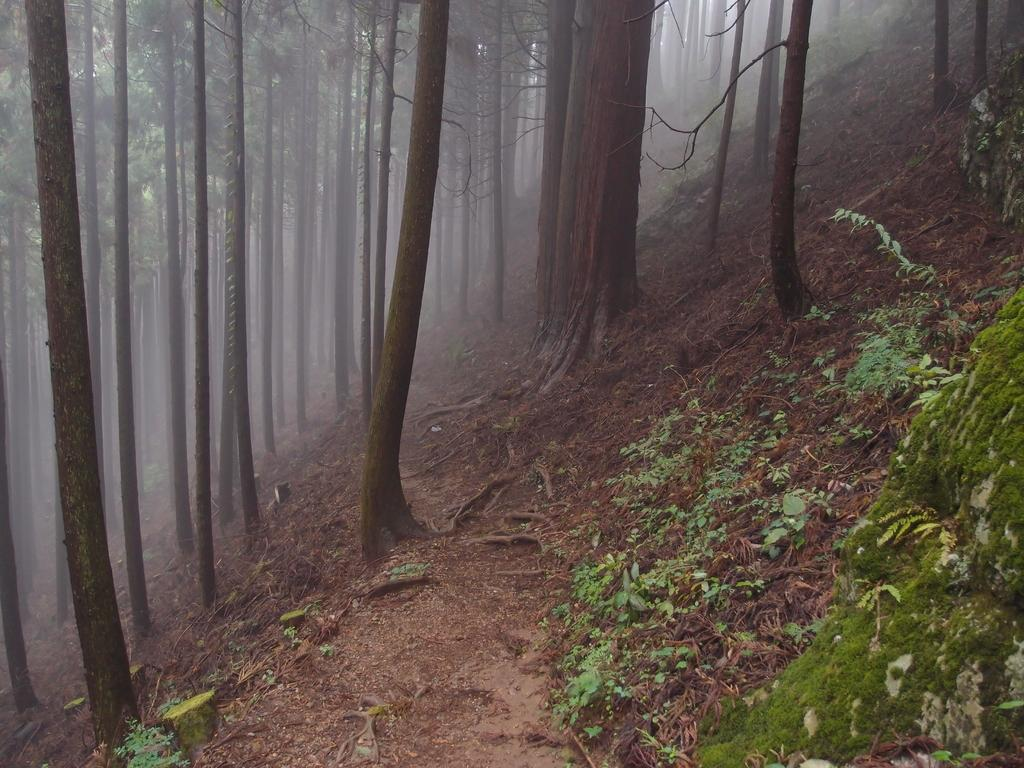What type of vegetation can be seen in the image? There are plants and trees in the image. Can you describe the setting where the plants and trees are located? The trees are on a path in the image. What atmospheric condition is present in the image? There is a fog in the image. What type of finger can be seen holding the bell in the image? There is no finger or bell present in the image. 